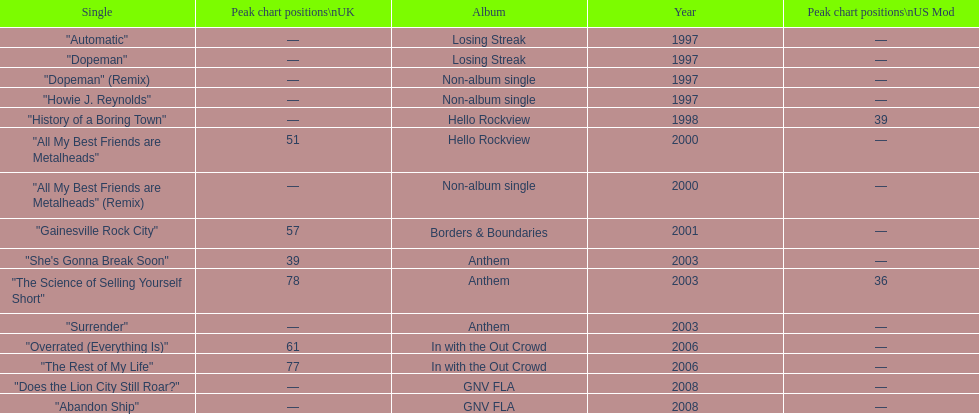Name one other single that was on the losing streak album besides "dopeman". "Automatic". 